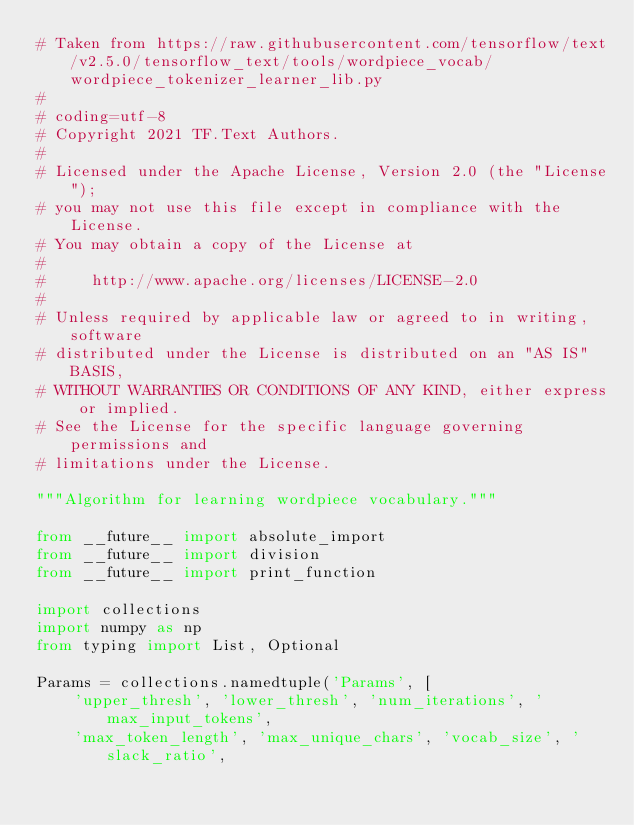<code> <loc_0><loc_0><loc_500><loc_500><_Python_># Taken from https://raw.githubusercontent.com/tensorflow/text/v2.5.0/tensorflow_text/tools/wordpiece_vocab/wordpiece_tokenizer_learner_lib.py
#
# coding=utf-8
# Copyright 2021 TF.Text Authors.
#
# Licensed under the Apache License, Version 2.0 (the "License");
# you may not use this file except in compliance with the License.
# You may obtain a copy of the License at
#
#     http://www.apache.org/licenses/LICENSE-2.0
#
# Unless required by applicable law or agreed to in writing, software
# distributed under the License is distributed on an "AS IS" BASIS,
# WITHOUT WARRANTIES OR CONDITIONS OF ANY KIND, either express or implied.
# See the License for the specific language governing permissions and
# limitations under the License.

"""Algorithm for learning wordpiece vocabulary."""

from __future__ import absolute_import
from __future__ import division
from __future__ import print_function

import collections
import numpy as np
from typing import List, Optional

Params = collections.namedtuple('Params', [
    'upper_thresh', 'lower_thresh', 'num_iterations', 'max_input_tokens',
    'max_token_length', 'max_unique_chars', 'vocab_size', 'slack_ratio',</code> 